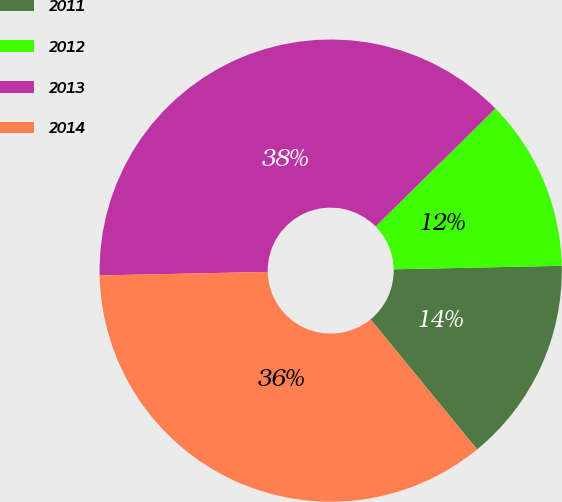Convert chart to OTSL. <chart><loc_0><loc_0><loc_500><loc_500><pie_chart><fcel>2011<fcel>2012<fcel>2013<fcel>2014<nl><fcel>14.41%<fcel>12.04%<fcel>37.96%<fcel>35.59%<nl></chart> 